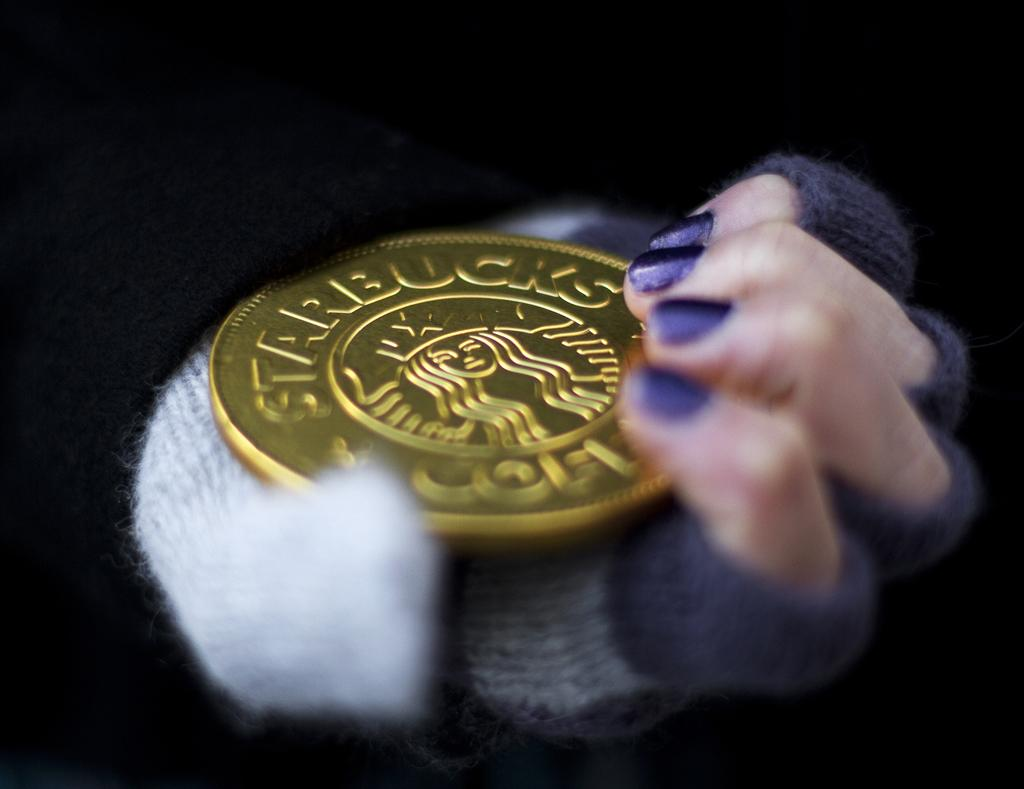<image>
Relay a brief, clear account of the picture shown. A big Starbucks coin is held by a hand with purple fingernails. 